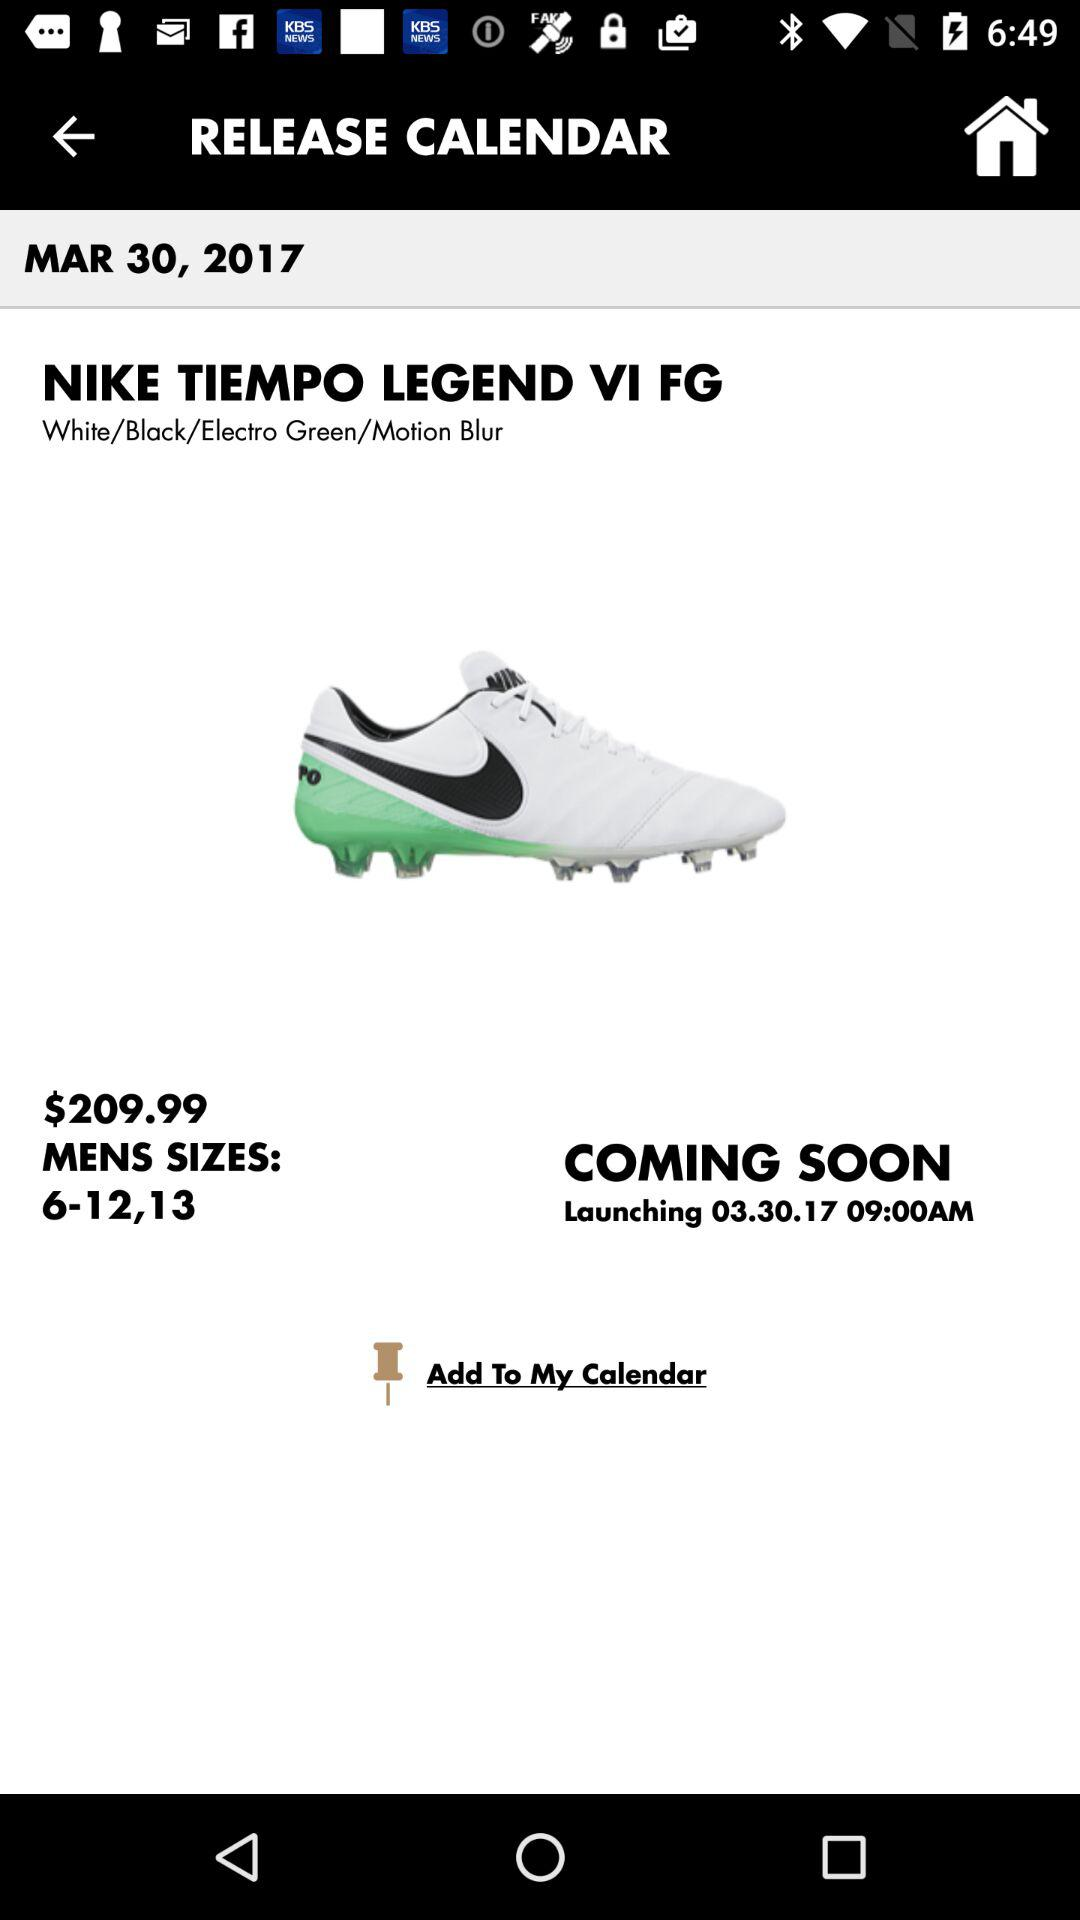What is the shoe price? The shoe price is $209.99. 